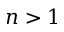<formula> <loc_0><loc_0><loc_500><loc_500>n > 1</formula> 